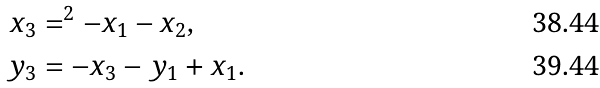Convert formula to latex. <formula><loc_0><loc_0><loc_500><loc_500>x _ { 3 } & = ^ { 2 } - x _ { 1 } - x _ { 2 } , \\ y _ { 3 } & = - x _ { 3 } - y _ { 1 } + x _ { 1 } .</formula> 